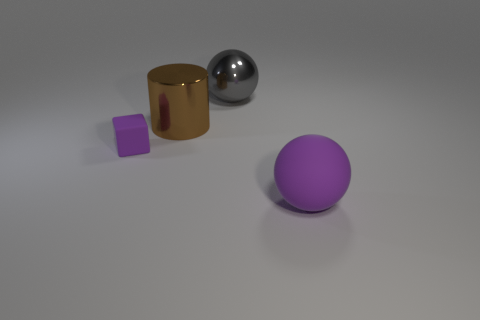There is a purple object that is in front of the matte thing that is behind the purple ball; what is its size?
Provide a short and direct response. Large. What color is the other big object that is the same shape as the large rubber thing?
Offer a terse response. Gray. What number of matte cubes are the same color as the matte sphere?
Provide a succinct answer. 1. Do the gray metal sphere and the cylinder have the same size?
Provide a short and direct response. Yes. What material is the big purple object?
Provide a short and direct response. Rubber. What is the color of the object that is the same material as the large gray sphere?
Your answer should be compact. Brown. Is the material of the gray sphere the same as the purple thing behind the large purple matte sphere?
Ensure brevity in your answer.  No. How many red cubes are made of the same material as the tiny purple block?
Your answer should be compact. 0. What is the shape of the large thing that is on the right side of the large gray shiny ball?
Give a very brief answer. Sphere. Is the ball left of the purple ball made of the same material as the purple object that is to the left of the brown metallic thing?
Offer a terse response. No. 